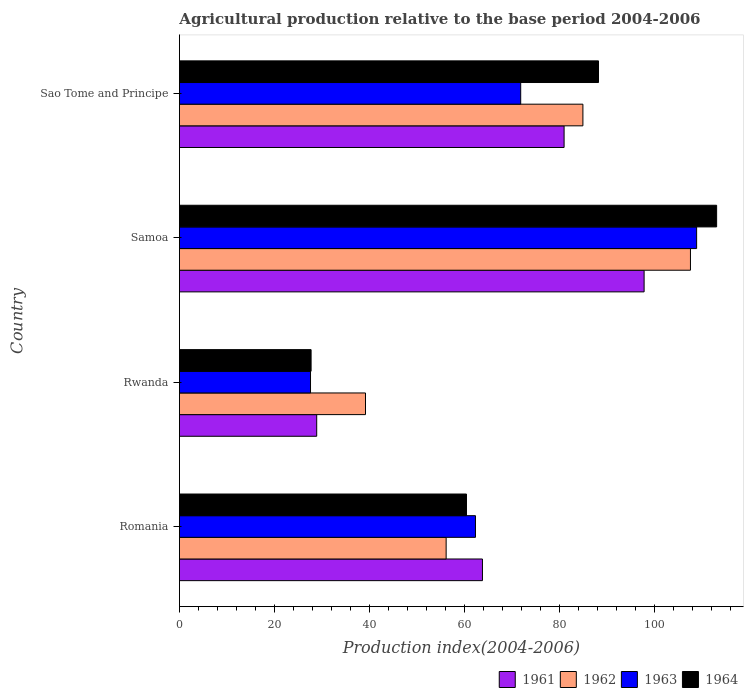How many groups of bars are there?
Make the answer very short. 4. Are the number of bars on each tick of the Y-axis equal?
Make the answer very short. Yes. How many bars are there on the 4th tick from the bottom?
Make the answer very short. 4. What is the label of the 4th group of bars from the top?
Offer a terse response. Romania. In how many cases, is the number of bars for a given country not equal to the number of legend labels?
Offer a terse response. 0. What is the agricultural production index in 1964 in Romania?
Your answer should be very brief. 60.41. Across all countries, what is the maximum agricultural production index in 1964?
Keep it short and to the point. 113.05. Across all countries, what is the minimum agricultural production index in 1961?
Provide a short and direct response. 28.89. In which country was the agricultural production index in 1962 maximum?
Your answer should be compact. Samoa. In which country was the agricultural production index in 1963 minimum?
Offer a terse response. Rwanda. What is the total agricultural production index in 1962 in the graph?
Ensure brevity in your answer.  287.74. What is the difference between the agricultural production index in 1963 in Romania and that in Rwanda?
Make the answer very short. 34.71. What is the difference between the agricultural production index in 1964 in Romania and the agricultural production index in 1962 in Samoa?
Your answer should be very brief. -47.13. What is the average agricultural production index in 1963 per country?
Offer a very short reply. 67.64. What is the difference between the agricultural production index in 1961 and agricultural production index in 1964 in Samoa?
Keep it short and to the point. -15.26. In how many countries, is the agricultural production index in 1964 greater than 28 ?
Provide a succinct answer. 3. What is the ratio of the agricultural production index in 1964 in Rwanda to that in Sao Tome and Principe?
Make the answer very short. 0.31. Is the agricultural production index in 1961 in Rwanda less than that in Sao Tome and Principe?
Ensure brevity in your answer.  Yes. What is the difference between the highest and the second highest agricultural production index in 1963?
Provide a short and direct response. 37.02. What is the difference between the highest and the lowest agricultural production index in 1963?
Give a very brief answer. 81.25. In how many countries, is the agricultural production index in 1964 greater than the average agricultural production index in 1964 taken over all countries?
Offer a terse response. 2. What does the 1st bar from the top in Samoa represents?
Provide a short and direct response. 1964. Is it the case that in every country, the sum of the agricultural production index in 1961 and agricultural production index in 1964 is greater than the agricultural production index in 1962?
Provide a short and direct response. Yes. Are the values on the major ticks of X-axis written in scientific E-notation?
Offer a very short reply. No. Does the graph contain grids?
Offer a very short reply. No. How are the legend labels stacked?
Your response must be concise. Horizontal. What is the title of the graph?
Ensure brevity in your answer.  Agricultural production relative to the base period 2004-2006. Does "1999" appear as one of the legend labels in the graph?
Offer a very short reply. No. What is the label or title of the X-axis?
Provide a short and direct response. Production index(2004-2006). What is the Production index(2004-2006) in 1961 in Romania?
Provide a short and direct response. 63.77. What is the Production index(2004-2006) in 1962 in Romania?
Ensure brevity in your answer.  56.13. What is the Production index(2004-2006) of 1963 in Romania?
Keep it short and to the point. 62.3. What is the Production index(2004-2006) in 1964 in Romania?
Keep it short and to the point. 60.41. What is the Production index(2004-2006) of 1961 in Rwanda?
Offer a very short reply. 28.89. What is the Production index(2004-2006) of 1962 in Rwanda?
Offer a terse response. 39.16. What is the Production index(2004-2006) in 1963 in Rwanda?
Your answer should be very brief. 27.59. What is the Production index(2004-2006) in 1964 in Rwanda?
Your answer should be very brief. 27.71. What is the Production index(2004-2006) in 1961 in Samoa?
Your response must be concise. 97.79. What is the Production index(2004-2006) of 1962 in Samoa?
Provide a short and direct response. 107.54. What is the Production index(2004-2006) in 1963 in Samoa?
Ensure brevity in your answer.  108.84. What is the Production index(2004-2006) in 1964 in Samoa?
Provide a short and direct response. 113.05. What is the Production index(2004-2006) of 1961 in Sao Tome and Principe?
Your answer should be compact. 80.95. What is the Production index(2004-2006) of 1962 in Sao Tome and Principe?
Ensure brevity in your answer.  84.91. What is the Production index(2004-2006) of 1963 in Sao Tome and Principe?
Offer a terse response. 71.82. What is the Production index(2004-2006) of 1964 in Sao Tome and Principe?
Ensure brevity in your answer.  88.19. Across all countries, what is the maximum Production index(2004-2006) in 1961?
Keep it short and to the point. 97.79. Across all countries, what is the maximum Production index(2004-2006) of 1962?
Your answer should be very brief. 107.54. Across all countries, what is the maximum Production index(2004-2006) in 1963?
Give a very brief answer. 108.84. Across all countries, what is the maximum Production index(2004-2006) in 1964?
Make the answer very short. 113.05. Across all countries, what is the minimum Production index(2004-2006) of 1961?
Provide a succinct answer. 28.89. Across all countries, what is the minimum Production index(2004-2006) of 1962?
Your answer should be very brief. 39.16. Across all countries, what is the minimum Production index(2004-2006) in 1963?
Ensure brevity in your answer.  27.59. Across all countries, what is the minimum Production index(2004-2006) in 1964?
Provide a succinct answer. 27.71. What is the total Production index(2004-2006) in 1961 in the graph?
Offer a very short reply. 271.4. What is the total Production index(2004-2006) in 1962 in the graph?
Offer a very short reply. 287.74. What is the total Production index(2004-2006) of 1963 in the graph?
Keep it short and to the point. 270.55. What is the total Production index(2004-2006) of 1964 in the graph?
Your response must be concise. 289.36. What is the difference between the Production index(2004-2006) in 1961 in Romania and that in Rwanda?
Provide a succinct answer. 34.88. What is the difference between the Production index(2004-2006) in 1962 in Romania and that in Rwanda?
Provide a short and direct response. 16.97. What is the difference between the Production index(2004-2006) of 1963 in Romania and that in Rwanda?
Offer a terse response. 34.71. What is the difference between the Production index(2004-2006) of 1964 in Romania and that in Rwanda?
Offer a very short reply. 32.7. What is the difference between the Production index(2004-2006) of 1961 in Romania and that in Samoa?
Make the answer very short. -34.02. What is the difference between the Production index(2004-2006) of 1962 in Romania and that in Samoa?
Your answer should be compact. -51.41. What is the difference between the Production index(2004-2006) in 1963 in Romania and that in Samoa?
Offer a very short reply. -46.54. What is the difference between the Production index(2004-2006) in 1964 in Romania and that in Samoa?
Keep it short and to the point. -52.64. What is the difference between the Production index(2004-2006) in 1961 in Romania and that in Sao Tome and Principe?
Offer a terse response. -17.18. What is the difference between the Production index(2004-2006) of 1962 in Romania and that in Sao Tome and Principe?
Provide a short and direct response. -28.78. What is the difference between the Production index(2004-2006) of 1963 in Romania and that in Sao Tome and Principe?
Offer a very short reply. -9.52. What is the difference between the Production index(2004-2006) of 1964 in Romania and that in Sao Tome and Principe?
Your response must be concise. -27.78. What is the difference between the Production index(2004-2006) of 1961 in Rwanda and that in Samoa?
Offer a very short reply. -68.9. What is the difference between the Production index(2004-2006) of 1962 in Rwanda and that in Samoa?
Provide a succinct answer. -68.38. What is the difference between the Production index(2004-2006) in 1963 in Rwanda and that in Samoa?
Your response must be concise. -81.25. What is the difference between the Production index(2004-2006) of 1964 in Rwanda and that in Samoa?
Your answer should be compact. -85.34. What is the difference between the Production index(2004-2006) of 1961 in Rwanda and that in Sao Tome and Principe?
Ensure brevity in your answer.  -52.06. What is the difference between the Production index(2004-2006) of 1962 in Rwanda and that in Sao Tome and Principe?
Provide a succinct answer. -45.75. What is the difference between the Production index(2004-2006) of 1963 in Rwanda and that in Sao Tome and Principe?
Your answer should be compact. -44.23. What is the difference between the Production index(2004-2006) of 1964 in Rwanda and that in Sao Tome and Principe?
Your response must be concise. -60.48. What is the difference between the Production index(2004-2006) of 1961 in Samoa and that in Sao Tome and Principe?
Your answer should be very brief. 16.84. What is the difference between the Production index(2004-2006) in 1962 in Samoa and that in Sao Tome and Principe?
Your answer should be very brief. 22.63. What is the difference between the Production index(2004-2006) in 1963 in Samoa and that in Sao Tome and Principe?
Provide a short and direct response. 37.02. What is the difference between the Production index(2004-2006) in 1964 in Samoa and that in Sao Tome and Principe?
Offer a terse response. 24.86. What is the difference between the Production index(2004-2006) in 1961 in Romania and the Production index(2004-2006) in 1962 in Rwanda?
Your response must be concise. 24.61. What is the difference between the Production index(2004-2006) in 1961 in Romania and the Production index(2004-2006) in 1963 in Rwanda?
Offer a terse response. 36.18. What is the difference between the Production index(2004-2006) in 1961 in Romania and the Production index(2004-2006) in 1964 in Rwanda?
Ensure brevity in your answer.  36.06. What is the difference between the Production index(2004-2006) in 1962 in Romania and the Production index(2004-2006) in 1963 in Rwanda?
Offer a very short reply. 28.54. What is the difference between the Production index(2004-2006) in 1962 in Romania and the Production index(2004-2006) in 1964 in Rwanda?
Your answer should be compact. 28.42. What is the difference between the Production index(2004-2006) of 1963 in Romania and the Production index(2004-2006) of 1964 in Rwanda?
Give a very brief answer. 34.59. What is the difference between the Production index(2004-2006) of 1961 in Romania and the Production index(2004-2006) of 1962 in Samoa?
Your answer should be very brief. -43.77. What is the difference between the Production index(2004-2006) of 1961 in Romania and the Production index(2004-2006) of 1963 in Samoa?
Provide a succinct answer. -45.07. What is the difference between the Production index(2004-2006) of 1961 in Romania and the Production index(2004-2006) of 1964 in Samoa?
Offer a terse response. -49.28. What is the difference between the Production index(2004-2006) in 1962 in Romania and the Production index(2004-2006) in 1963 in Samoa?
Offer a very short reply. -52.71. What is the difference between the Production index(2004-2006) in 1962 in Romania and the Production index(2004-2006) in 1964 in Samoa?
Keep it short and to the point. -56.92. What is the difference between the Production index(2004-2006) of 1963 in Romania and the Production index(2004-2006) of 1964 in Samoa?
Give a very brief answer. -50.75. What is the difference between the Production index(2004-2006) of 1961 in Romania and the Production index(2004-2006) of 1962 in Sao Tome and Principe?
Your answer should be very brief. -21.14. What is the difference between the Production index(2004-2006) in 1961 in Romania and the Production index(2004-2006) in 1963 in Sao Tome and Principe?
Offer a terse response. -8.05. What is the difference between the Production index(2004-2006) of 1961 in Romania and the Production index(2004-2006) of 1964 in Sao Tome and Principe?
Ensure brevity in your answer.  -24.42. What is the difference between the Production index(2004-2006) of 1962 in Romania and the Production index(2004-2006) of 1963 in Sao Tome and Principe?
Give a very brief answer. -15.69. What is the difference between the Production index(2004-2006) in 1962 in Romania and the Production index(2004-2006) in 1964 in Sao Tome and Principe?
Your answer should be compact. -32.06. What is the difference between the Production index(2004-2006) in 1963 in Romania and the Production index(2004-2006) in 1964 in Sao Tome and Principe?
Your answer should be compact. -25.89. What is the difference between the Production index(2004-2006) of 1961 in Rwanda and the Production index(2004-2006) of 1962 in Samoa?
Provide a succinct answer. -78.65. What is the difference between the Production index(2004-2006) in 1961 in Rwanda and the Production index(2004-2006) in 1963 in Samoa?
Provide a succinct answer. -79.95. What is the difference between the Production index(2004-2006) in 1961 in Rwanda and the Production index(2004-2006) in 1964 in Samoa?
Offer a very short reply. -84.16. What is the difference between the Production index(2004-2006) in 1962 in Rwanda and the Production index(2004-2006) in 1963 in Samoa?
Offer a very short reply. -69.68. What is the difference between the Production index(2004-2006) in 1962 in Rwanda and the Production index(2004-2006) in 1964 in Samoa?
Provide a succinct answer. -73.89. What is the difference between the Production index(2004-2006) in 1963 in Rwanda and the Production index(2004-2006) in 1964 in Samoa?
Make the answer very short. -85.46. What is the difference between the Production index(2004-2006) of 1961 in Rwanda and the Production index(2004-2006) of 1962 in Sao Tome and Principe?
Your response must be concise. -56.02. What is the difference between the Production index(2004-2006) of 1961 in Rwanda and the Production index(2004-2006) of 1963 in Sao Tome and Principe?
Give a very brief answer. -42.93. What is the difference between the Production index(2004-2006) in 1961 in Rwanda and the Production index(2004-2006) in 1964 in Sao Tome and Principe?
Your response must be concise. -59.3. What is the difference between the Production index(2004-2006) in 1962 in Rwanda and the Production index(2004-2006) in 1963 in Sao Tome and Principe?
Your response must be concise. -32.66. What is the difference between the Production index(2004-2006) in 1962 in Rwanda and the Production index(2004-2006) in 1964 in Sao Tome and Principe?
Your answer should be very brief. -49.03. What is the difference between the Production index(2004-2006) in 1963 in Rwanda and the Production index(2004-2006) in 1964 in Sao Tome and Principe?
Give a very brief answer. -60.6. What is the difference between the Production index(2004-2006) of 1961 in Samoa and the Production index(2004-2006) of 1962 in Sao Tome and Principe?
Provide a succinct answer. 12.88. What is the difference between the Production index(2004-2006) in 1961 in Samoa and the Production index(2004-2006) in 1963 in Sao Tome and Principe?
Offer a terse response. 25.97. What is the difference between the Production index(2004-2006) of 1961 in Samoa and the Production index(2004-2006) of 1964 in Sao Tome and Principe?
Keep it short and to the point. 9.6. What is the difference between the Production index(2004-2006) in 1962 in Samoa and the Production index(2004-2006) in 1963 in Sao Tome and Principe?
Offer a very short reply. 35.72. What is the difference between the Production index(2004-2006) in 1962 in Samoa and the Production index(2004-2006) in 1964 in Sao Tome and Principe?
Make the answer very short. 19.35. What is the difference between the Production index(2004-2006) of 1963 in Samoa and the Production index(2004-2006) of 1964 in Sao Tome and Principe?
Offer a terse response. 20.65. What is the average Production index(2004-2006) in 1961 per country?
Offer a terse response. 67.85. What is the average Production index(2004-2006) in 1962 per country?
Your response must be concise. 71.94. What is the average Production index(2004-2006) of 1963 per country?
Offer a terse response. 67.64. What is the average Production index(2004-2006) of 1964 per country?
Give a very brief answer. 72.34. What is the difference between the Production index(2004-2006) of 1961 and Production index(2004-2006) of 1962 in Romania?
Give a very brief answer. 7.64. What is the difference between the Production index(2004-2006) of 1961 and Production index(2004-2006) of 1963 in Romania?
Give a very brief answer. 1.47. What is the difference between the Production index(2004-2006) in 1961 and Production index(2004-2006) in 1964 in Romania?
Offer a terse response. 3.36. What is the difference between the Production index(2004-2006) in 1962 and Production index(2004-2006) in 1963 in Romania?
Make the answer very short. -6.17. What is the difference between the Production index(2004-2006) in 1962 and Production index(2004-2006) in 1964 in Romania?
Provide a short and direct response. -4.28. What is the difference between the Production index(2004-2006) in 1963 and Production index(2004-2006) in 1964 in Romania?
Your answer should be very brief. 1.89. What is the difference between the Production index(2004-2006) in 1961 and Production index(2004-2006) in 1962 in Rwanda?
Give a very brief answer. -10.27. What is the difference between the Production index(2004-2006) in 1961 and Production index(2004-2006) in 1963 in Rwanda?
Offer a terse response. 1.3. What is the difference between the Production index(2004-2006) of 1961 and Production index(2004-2006) of 1964 in Rwanda?
Your response must be concise. 1.18. What is the difference between the Production index(2004-2006) of 1962 and Production index(2004-2006) of 1963 in Rwanda?
Your answer should be very brief. 11.57. What is the difference between the Production index(2004-2006) in 1962 and Production index(2004-2006) in 1964 in Rwanda?
Ensure brevity in your answer.  11.45. What is the difference between the Production index(2004-2006) in 1963 and Production index(2004-2006) in 1964 in Rwanda?
Your answer should be very brief. -0.12. What is the difference between the Production index(2004-2006) in 1961 and Production index(2004-2006) in 1962 in Samoa?
Provide a short and direct response. -9.75. What is the difference between the Production index(2004-2006) of 1961 and Production index(2004-2006) of 1963 in Samoa?
Make the answer very short. -11.05. What is the difference between the Production index(2004-2006) in 1961 and Production index(2004-2006) in 1964 in Samoa?
Give a very brief answer. -15.26. What is the difference between the Production index(2004-2006) of 1962 and Production index(2004-2006) of 1963 in Samoa?
Give a very brief answer. -1.3. What is the difference between the Production index(2004-2006) in 1962 and Production index(2004-2006) in 1964 in Samoa?
Ensure brevity in your answer.  -5.51. What is the difference between the Production index(2004-2006) of 1963 and Production index(2004-2006) of 1964 in Samoa?
Make the answer very short. -4.21. What is the difference between the Production index(2004-2006) in 1961 and Production index(2004-2006) in 1962 in Sao Tome and Principe?
Your answer should be compact. -3.96. What is the difference between the Production index(2004-2006) of 1961 and Production index(2004-2006) of 1963 in Sao Tome and Principe?
Keep it short and to the point. 9.13. What is the difference between the Production index(2004-2006) of 1961 and Production index(2004-2006) of 1964 in Sao Tome and Principe?
Your response must be concise. -7.24. What is the difference between the Production index(2004-2006) of 1962 and Production index(2004-2006) of 1963 in Sao Tome and Principe?
Provide a short and direct response. 13.09. What is the difference between the Production index(2004-2006) of 1962 and Production index(2004-2006) of 1964 in Sao Tome and Principe?
Provide a short and direct response. -3.28. What is the difference between the Production index(2004-2006) in 1963 and Production index(2004-2006) in 1964 in Sao Tome and Principe?
Keep it short and to the point. -16.37. What is the ratio of the Production index(2004-2006) of 1961 in Romania to that in Rwanda?
Offer a terse response. 2.21. What is the ratio of the Production index(2004-2006) in 1962 in Romania to that in Rwanda?
Your answer should be compact. 1.43. What is the ratio of the Production index(2004-2006) of 1963 in Romania to that in Rwanda?
Provide a succinct answer. 2.26. What is the ratio of the Production index(2004-2006) in 1964 in Romania to that in Rwanda?
Your answer should be very brief. 2.18. What is the ratio of the Production index(2004-2006) in 1961 in Romania to that in Samoa?
Give a very brief answer. 0.65. What is the ratio of the Production index(2004-2006) of 1962 in Romania to that in Samoa?
Give a very brief answer. 0.52. What is the ratio of the Production index(2004-2006) of 1963 in Romania to that in Samoa?
Make the answer very short. 0.57. What is the ratio of the Production index(2004-2006) of 1964 in Romania to that in Samoa?
Offer a terse response. 0.53. What is the ratio of the Production index(2004-2006) in 1961 in Romania to that in Sao Tome and Principe?
Give a very brief answer. 0.79. What is the ratio of the Production index(2004-2006) of 1962 in Romania to that in Sao Tome and Principe?
Give a very brief answer. 0.66. What is the ratio of the Production index(2004-2006) in 1963 in Romania to that in Sao Tome and Principe?
Your answer should be very brief. 0.87. What is the ratio of the Production index(2004-2006) of 1964 in Romania to that in Sao Tome and Principe?
Offer a terse response. 0.69. What is the ratio of the Production index(2004-2006) in 1961 in Rwanda to that in Samoa?
Your answer should be very brief. 0.3. What is the ratio of the Production index(2004-2006) of 1962 in Rwanda to that in Samoa?
Your answer should be compact. 0.36. What is the ratio of the Production index(2004-2006) in 1963 in Rwanda to that in Samoa?
Your response must be concise. 0.25. What is the ratio of the Production index(2004-2006) in 1964 in Rwanda to that in Samoa?
Offer a terse response. 0.25. What is the ratio of the Production index(2004-2006) in 1961 in Rwanda to that in Sao Tome and Principe?
Give a very brief answer. 0.36. What is the ratio of the Production index(2004-2006) in 1962 in Rwanda to that in Sao Tome and Principe?
Provide a succinct answer. 0.46. What is the ratio of the Production index(2004-2006) of 1963 in Rwanda to that in Sao Tome and Principe?
Provide a succinct answer. 0.38. What is the ratio of the Production index(2004-2006) of 1964 in Rwanda to that in Sao Tome and Principe?
Provide a short and direct response. 0.31. What is the ratio of the Production index(2004-2006) of 1961 in Samoa to that in Sao Tome and Principe?
Your response must be concise. 1.21. What is the ratio of the Production index(2004-2006) in 1962 in Samoa to that in Sao Tome and Principe?
Give a very brief answer. 1.27. What is the ratio of the Production index(2004-2006) in 1963 in Samoa to that in Sao Tome and Principe?
Provide a short and direct response. 1.52. What is the ratio of the Production index(2004-2006) of 1964 in Samoa to that in Sao Tome and Principe?
Your answer should be compact. 1.28. What is the difference between the highest and the second highest Production index(2004-2006) in 1961?
Ensure brevity in your answer.  16.84. What is the difference between the highest and the second highest Production index(2004-2006) in 1962?
Offer a terse response. 22.63. What is the difference between the highest and the second highest Production index(2004-2006) of 1963?
Make the answer very short. 37.02. What is the difference between the highest and the second highest Production index(2004-2006) of 1964?
Keep it short and to the point. 24.86. What is the difference between the highest and the lowest Production index(2004-2006) in 1961?
Provide a succinct answer. 68.9. What is the difference between the highest and the lowest Production index(2004-2006) in 1962?
Keep it short and to the point. 68.38. What is the difference between the highest and the lowest Production index(2004-2006) of 1963?
Make the answer very short. 81.25. What is the difference between the highest and the lowest Production index(2004-2006) in 1964?
Provide a succinct answer. 85.34. 